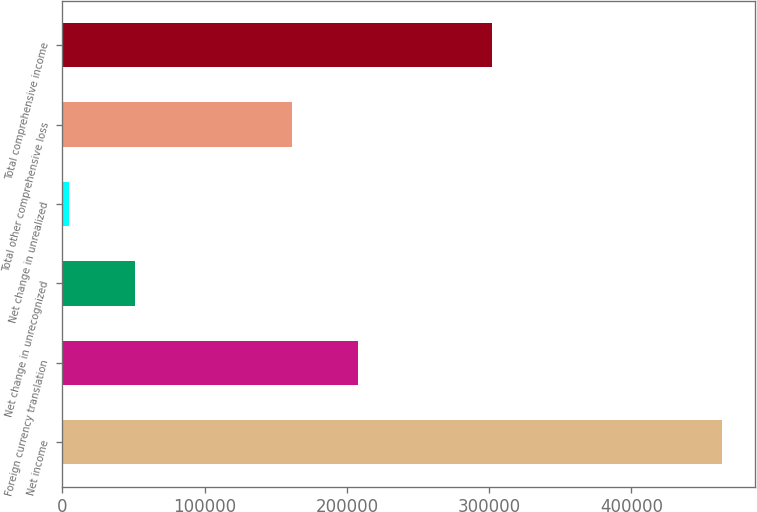Convert chart. <chart><loc_0><loc_0><loc_500><loc_500><bar_chart><fcel>Net income<fcel>Foreign currency translation<fcel>Net change in unrecognized<fcel>Net change in unrealized<fcel>Total other comprehensive loss<fcel>Total comprehensive income<nl><fcel>463975<fcel>207611<fcel>50817.4<fcel>4911<fcel>161705<fcel>302270<nl></chart> 